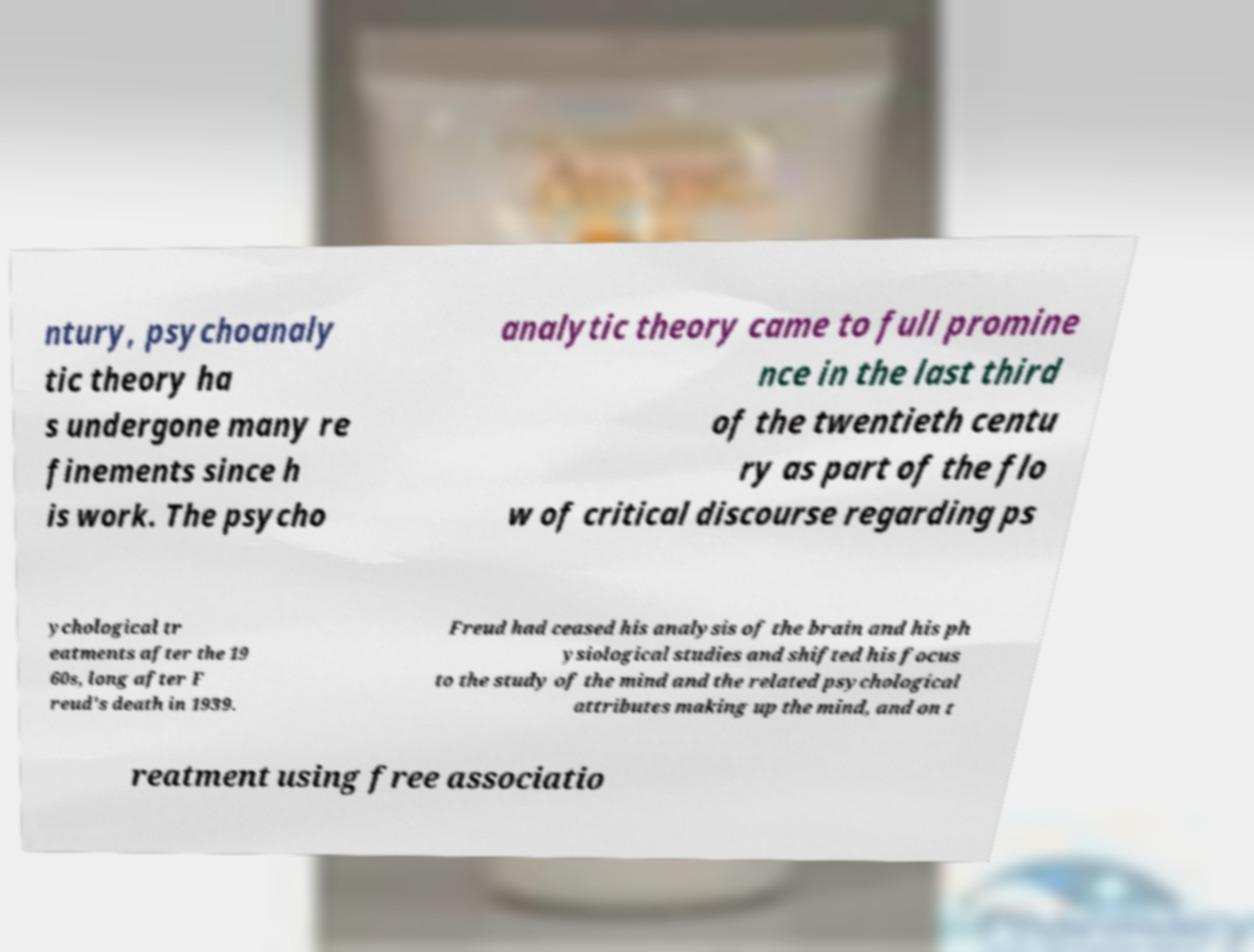Can you read and provide the text displayed in the image?This photo seems to have some interesting text. Can you extract and type it out for me? ntury, psychoanaly tic theory ha s undergone many re finements since h is work. The psycho analytic theory came to full promine nce in the last third of the twentieth centu ry as part of the flo w of critical discourse regarding ps ychological tr eatments after the 19 60s, long after F reud's death in 1939. Freud had ceased his analysis of the brain and his ph ysiological studies and shifted his focus to the study of the mind and the related psychological attributes making up the mind, and on t reatment using free associatio 